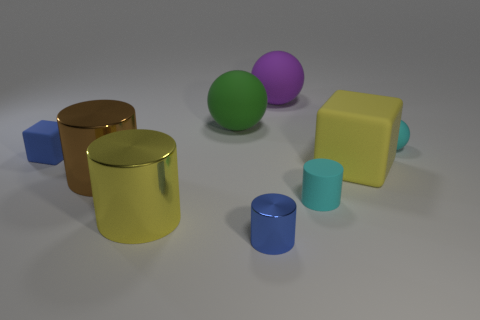There is a small object that is the same color as the tiny matte sphere; what is its shape?
Offer a terse response. Cylinder. There is a metallic cylinder that is the same color as the large matte cube; what size is it?
Provide a succinct answer. Large. There is a cyan matte object that is in front of the tiny cyan matte object behind the large matte object in front of the small ball; how big is it?
Provide a succinct answer. Small. There is a small blue thing that is behind the big yellow thing that is on the right side of the purple rubber thing; are there any large green balls that are in front of it?
Your response must be concise. No. Is the number of purple matte balls greater than the number of big green shiny cylinders?
Provide a short and direct response. Yes. There is a matte cube that is to the right of the tiny cyan rubber cylinder; what color is it?
Your answer should be compact. Yellow. Are there more yellow metal objects left of the large purple matte ball than brown cylinders?
Ensure brevity in your answer.  No. Do the yellow block and the purple sphere have the same material?
Offer a very short reply. Yes. What number of other things are there of the same shape as the small blue shiny object?
Offer a terse response. 3. Is there anything else that is made of the same material as the big yellow block?
Ensure brevity in your answer.  Yes. 